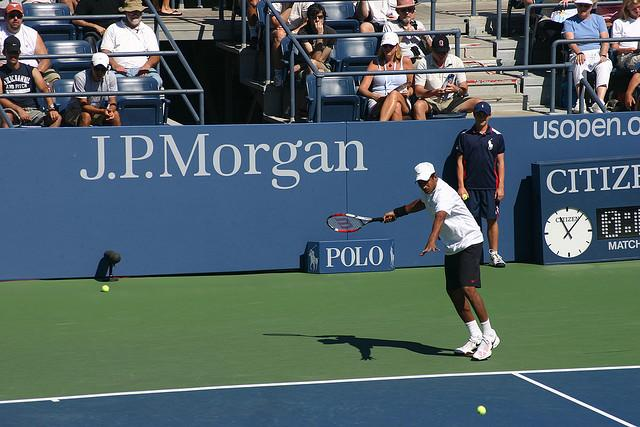What is the finance company advertised on the wall next to the tennis player? Please explain your reasoning. jp morgan. A business logo can be seen behind a tennis player on a court. companies advertise at professional sporting events. 